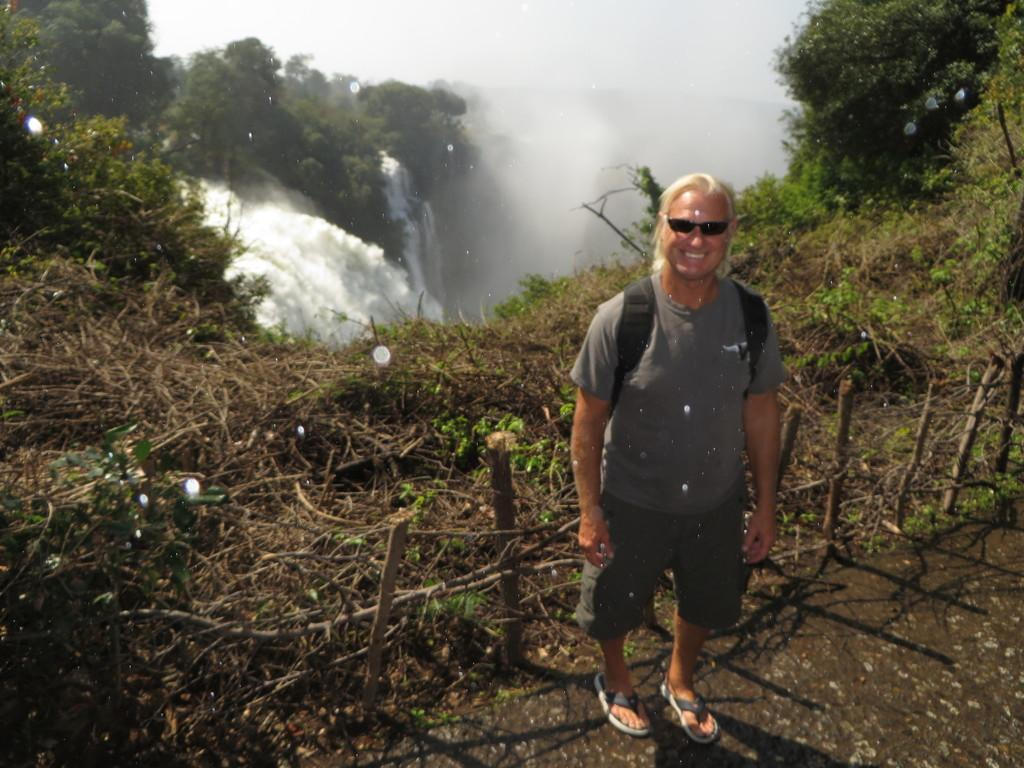What is the man in the image doing? The man is standing in the image. What expression does the man have on his face? The man is smiling. What accessories is the man wearing? The man is wearing sunglasses and a backpack. What type of natural scenery can be seen in the image? There are trees and a waterfall visible in the image. What type of operation is being performed on the window in the image? There is no window present in the image, and therefore no operation is being performed on it. 